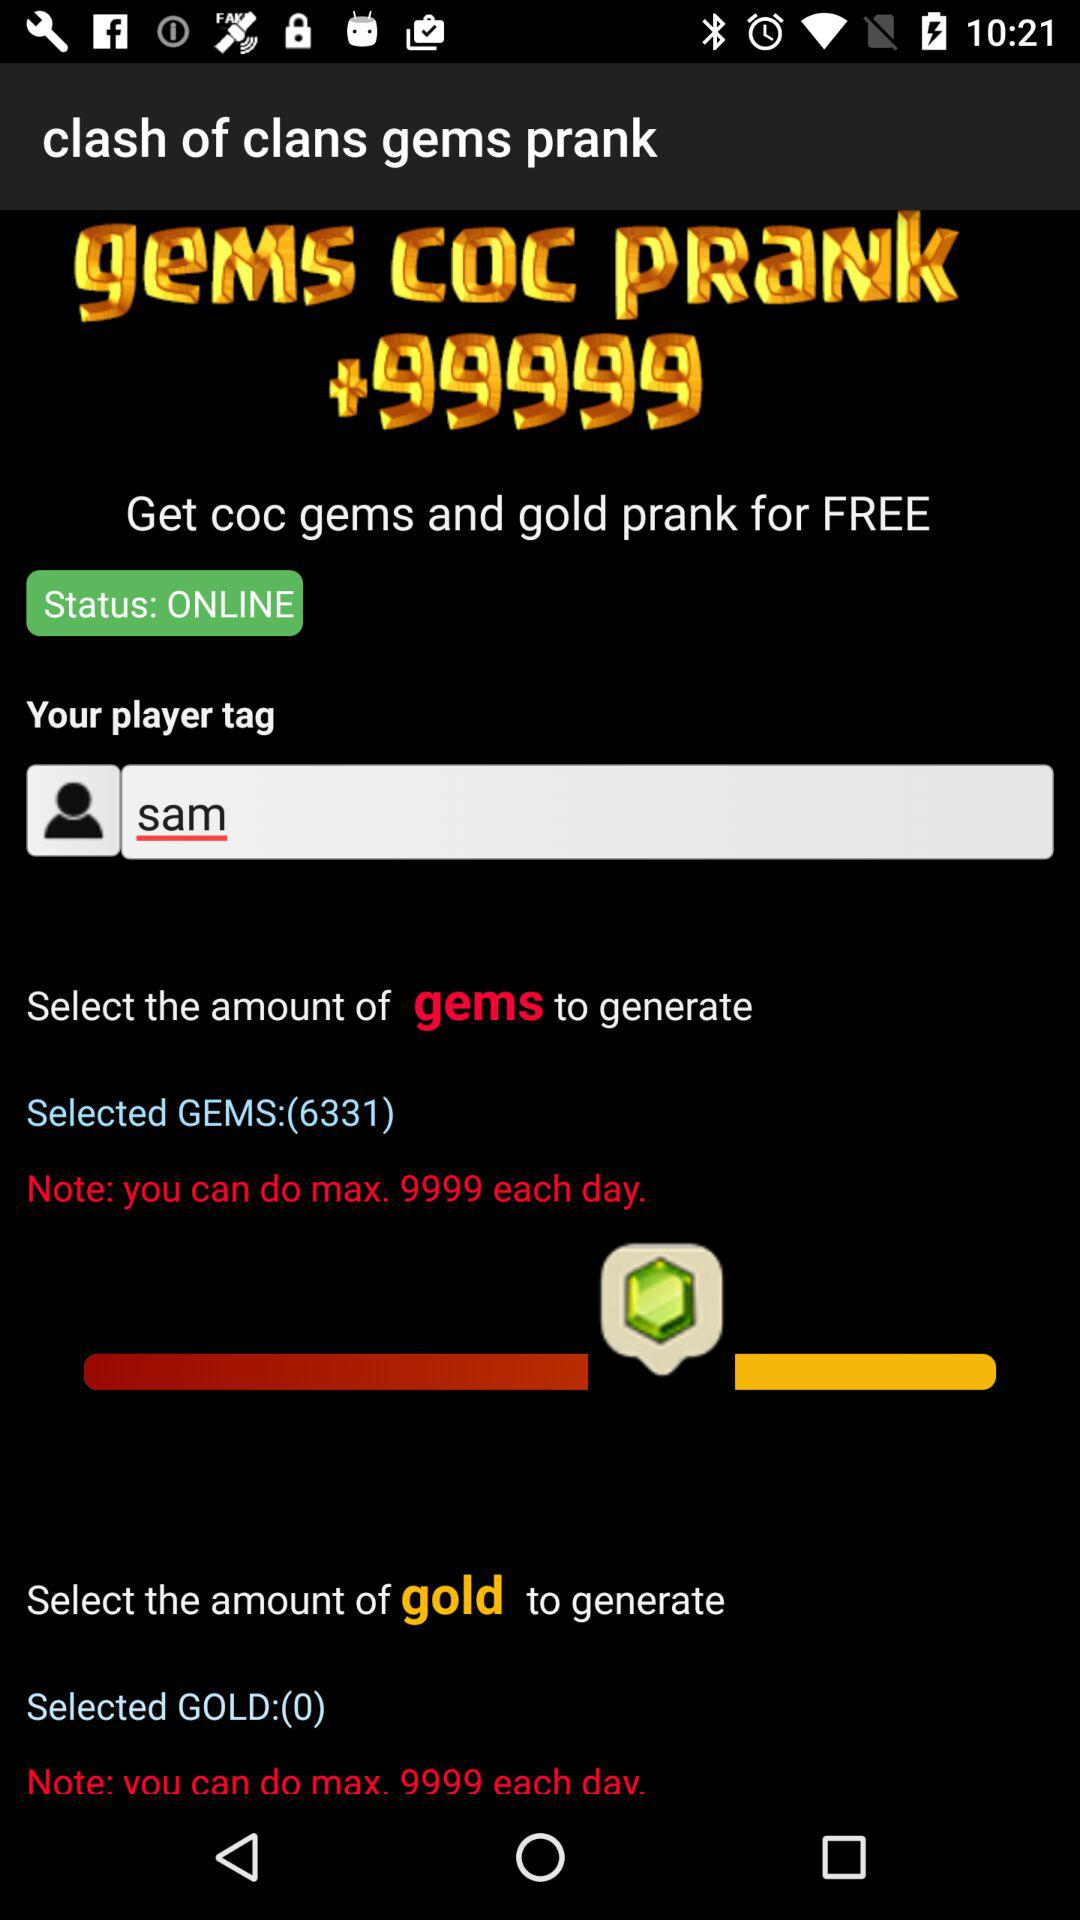What is the maximum number of gems I can generate per day?
Answer the question using a single word or phrase. 9999 